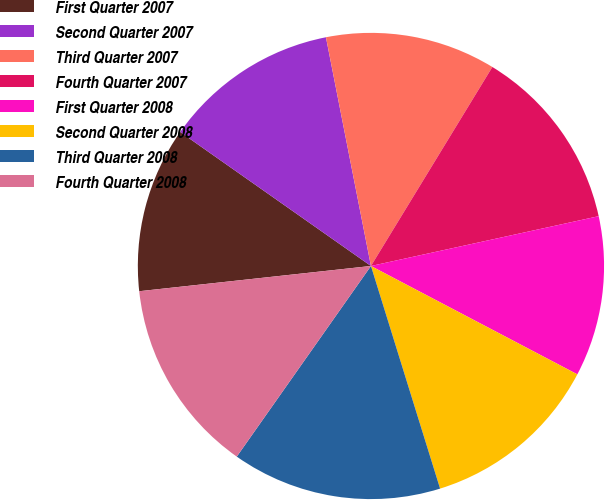Convert chart to OTSL. <chart><loc_0><loc_0><loc_500><loc_500><pie_chart><fcel>First Quarter 2007<fcel>Second Quarter 2007<fcel>Third Quarter 2007<fcel>Fourth Quarter 2007<fcel>First Quarter 2008<fcel>Second Quarter 2008<fcel>Third Quarter 2008<fcel>Fourth Quarter 2008<nl><fcel>11.47%<fcel>12.16%<fcel>11.81%<fcel>12.85%<fcel>11.12%<fcel>12.51%<fcel>14.55%<fcel>13.51%<nl></chart> 